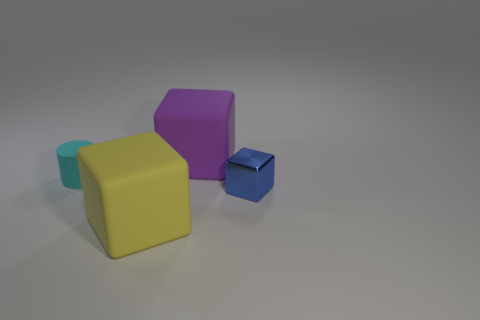Add 2 big blue shiny cylinders. How many objects exist? 6 Subtract all blocks. How many objects are left? 1 Add 1 rubber cylinders. How many rubber cylinders exist? 2 Subtract 1 blue blocks. How many objects are left? 3 Subtract all tiny red blocks. Subtract all yellow cubes. How many objects are left? 3 Add 3 small cubes. How many small cubes are left? 4 